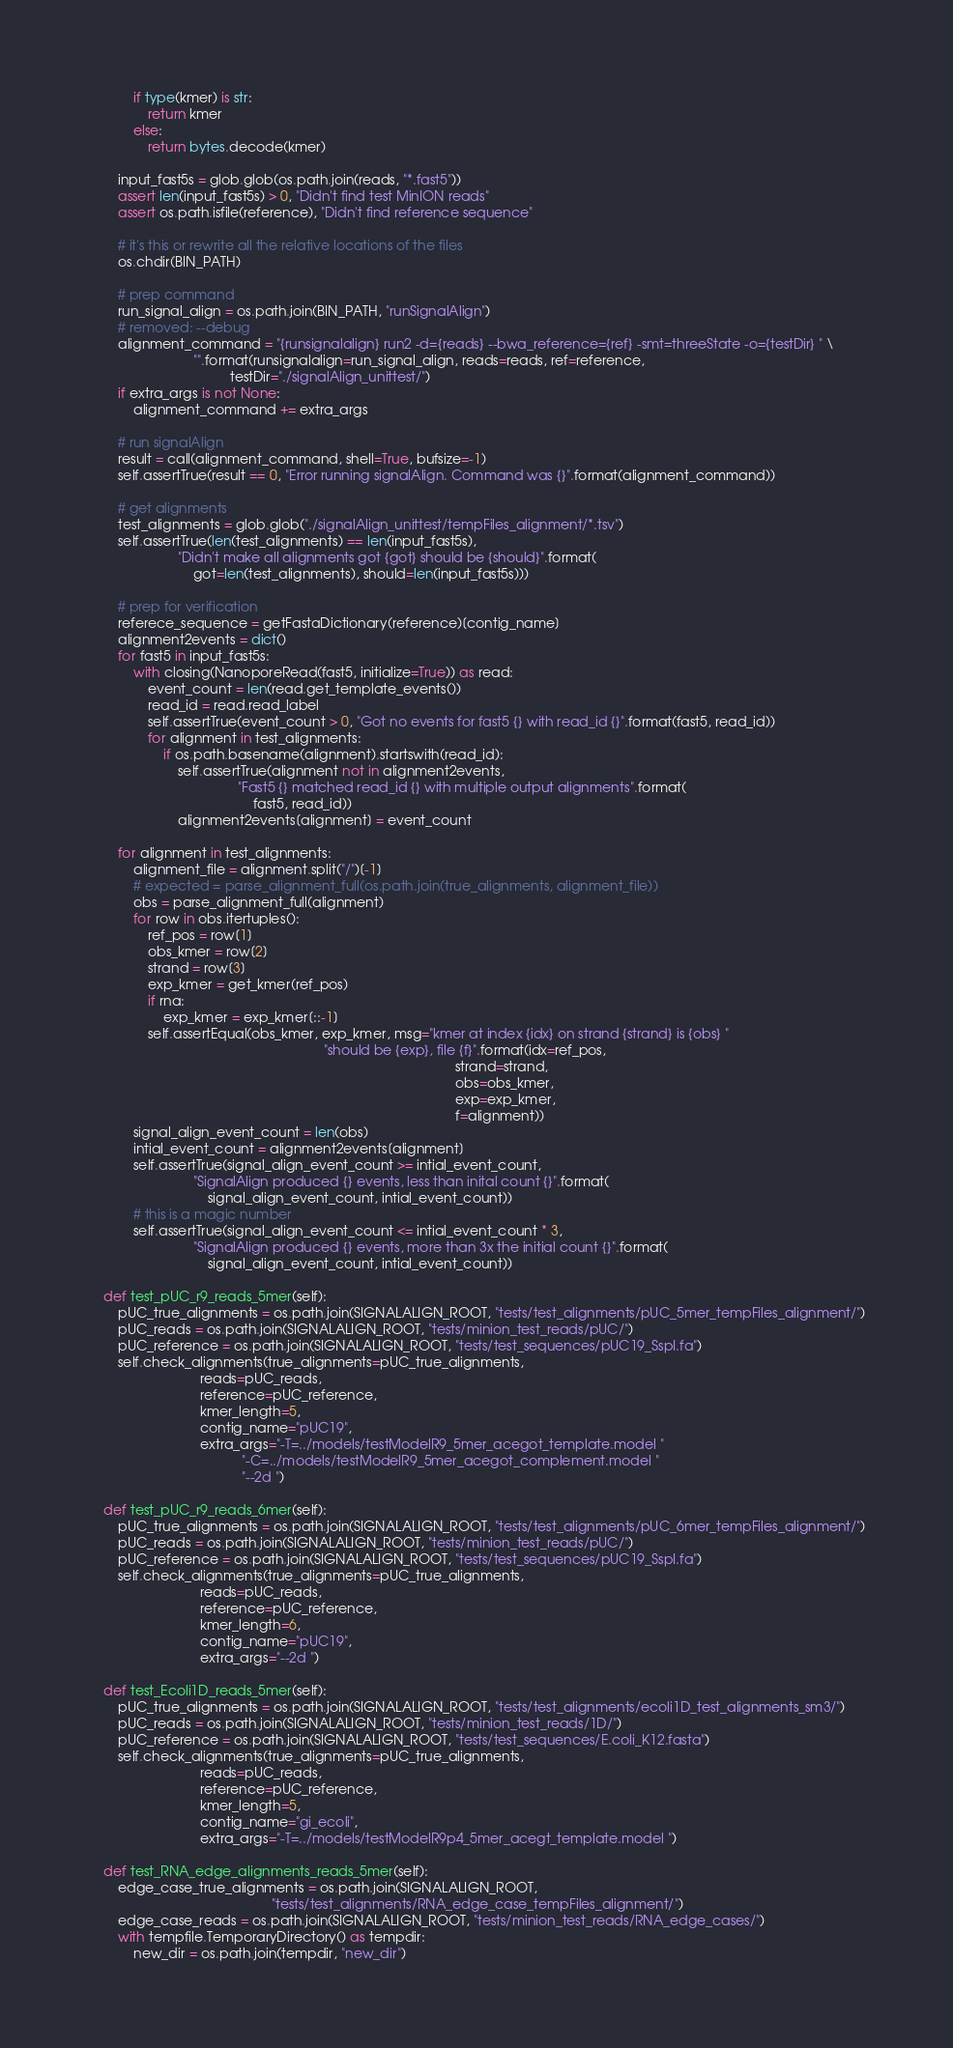Convert code to text. <code><loc_0><loc_0><loc_500><loc_500><_Python_>            if type(kmer) is str:
                return kmer
            else:
                return bytes.decode(kmer)

        input_fast5s = glob.glob(os.path.join(reads, "*.fast5"))
        assert len(input_fast5s) > 0, "Didn't find test MinION reads"
        assert os.path.isfile(reference), "Didn't find reference sequence"

        # it's this or rewrite all the relative locations of the files
        os.chdir(BIN_PATH)

        # prep command
        run_signal_align = os.path.join(BIN_PATH, "runSignalAlign")
        # removed: --debug
        alignment_command = "{runsignalalign} run2 -d={reads} --bwa_reference={ref} -smt=threeState -o={testDir} " \
                            "".format(runsignalalign=run_signal_align, reads=reads, ref=reference,
                                      testDir="./signalAlign_unittest/")
        if extra_args is not None:
            alignment_command += extra_args

        # run signalAlign
        result = call(alignment_command, shell=True, bufsize=-1)
        self.assertTrue(result == 0, "Error running signalAlign. Command was {}".format(alignment_command))

        # get alignments
        test_alignments = glob.glob("./signalAlign_unittest/tempFiles_alignment/*.tsv")
        self.assertTrue(len(test_alignments) == len(input_fast5s),
                        "Didn't make all alignments got {got} should be {should}".format(
                            got=len(test_alignments), should=len(input_fast5s)))

        # prep for verification
        referece_sequence = getFastaDictionary(reference)[contig_name]
        alignment2events = dict()
        for fast5 in input_fast5s:
            with closing(NanoporeRead(fast5, initialize=True)) as read:
                event_count = len(read.get_template_events())
                read_id = read.read_label
                self.assertTrue(event_count > 0, "Got no events for fast5 {} with read_id {}".format(fast5, read_id))
                for alignment in test_alignments:
                    if os.path.basename(alignment).startswith(read_id):
                        self.assertTrue(alignment not in alignment2events,
                                        "Fast5 {} matched read_id {} with multiple output alignments".format(
                                            fast5, read_id))
                        alignment2events[alignment] = event_count

        for alignment in test_alignments:
            alignment_file = alignment.split("/")[-1]
            # expected = parse_alignment_full(os.path.join(true_alignments, alignment_file))
            obs = parse_alignment_full(alignment)
            for row in obs.itertuples():
                ref_pos = row[1]
                obs_kmer = row[2]
                strand = row[3]
                exp_kmer = get_kmer(ref_pos)
                if rna:
                    exp_kmer = exp_kmer[::-1]
                self.assertEqual(obs_kmer, exp_kmer, msg="kmer at index {idx} on strand {strand} is {obs} "
                                                               "should be {exp}, file {f}".format(idx=ref_pos,
                                                                                                  strand=strand,
                                                                                                  obs=obs_kmer,
                                                                                                  exp=exp_kmer,
                                                                                                  f=alignment))
            signal_align_event_count = len(obs)
            intial_event_count = alignment2events[alignment]
            self.assertTrue(signal_align_event_count >= intial_event_count,
                            "SignalAlign produced {} events, less than inital count {}".format(
                                signal_align_event_count, intial_event_count))
            # this is a magic number
            self.assertTrue(signal_align_event_count <= intial_event_count * 3,
                            "SignalAlign produced {} events, more than 3x the initial count {}".format(
                                signal_align_event_count, intial_event_count))

    def test_pUC_r9_reads_5mer(self):
        pUC_true_alignments = os.path.join(SIGNALALIGN_ROOT, "tests/test_alignments/pUC_5mer_tempFiles_alignment/")
        pUC_reads = os.path.join(SIGNALALIGN_ROOT, "tests/minion_test_reads/pUC/")
        pUC_reference = os.path.join(SIGNALALIGN_ROOT, "tests/test_sequences/pUC19_SspI.fa")
        self.check_alignments(true_alignments=pUC_true_alignments,
                              reads=pUC_reads,
                              reference=pUC_reference,
                              kmer_length=5,
                              contig_name="pUC19",
                              extra_args="-T=../models/testModelR9_5mer_acegot_template.model "
                                         "-C=../models/testModelR9_5mer_acegot_complement.model "
                                         "--2d ")

    def test_pUC_r9_reads_6mer(self):
        pUC_true_alignments = os.path.join(SIGNALALIGN_ROOT, "tests/test_alignments/pUC_6mer_tempFiles_alignment/")
        pUC_reads = os.path.join(SIGNALALIGN_ROOT, "tests/minion_test_reads/pUC/")
        pUC_reference = os.path.join(SIGNALALIGN_ROOT, "tests/test_sequences/pUC19_SspI.fa")
        self.check_alignments(true_alignments=pUC_true_alignments,
                              reads=pUC_reads,
                              reference=pUC_reference,
                              kmer_length=6,
                              contig_name="pUC19",
                              extra_args="--2d ")

    def test_Ecoli1D_reads_5mer(self):
        pUC_true_alignments = os.path.join(SIGNALALIGN_ROOT, "tests/test_alignments/ecoli1D_test_alignments_sm3/")
        pUC_reads = os.path.join(SIGNALALIGN_ROOT, "tests/minion_test_reads/1D/")
        pUC_reference = os.path.join(SIGNALALIGN_ROOT, "tests/test_sequences/E.coli_K12.fasta")
        self.check_alignments(true_alignments=pUC_true_alignments,
                              reads=pUC_reads,
                              reference=pUC_reference,
                              kmer_length=5,
                              contig_name="gi_ecoli",
                              extra_args="-T=../models/testModelR9p4_5mer_acegt_template.model ")

    def test_RNA_edge_alignments_reads_5mer(self):
        edge_case_true_alignments = os.path.join(SIGNALALIGN_ROOT,
                                                 "tests/test_alignments/RNA_edge_case_tempFiles_alignment/")
        edge_case_reads = os.path.join(SIGNALALIGN_ROOT, "tests/minion_test_reads/RNA_edge_cases/")
        with tempfile.TemporaryDirectory() as tempdir:
            new_dir = os.path.join(tempdir, "new_dir")</code> 